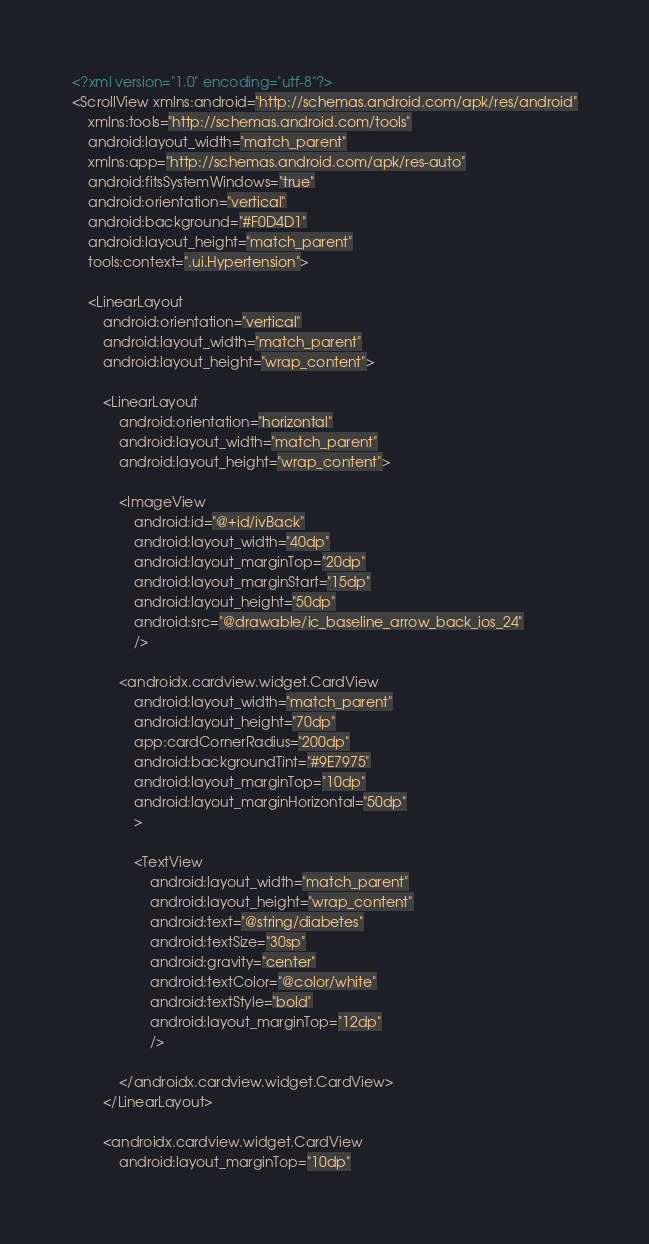<code> <loc_0><loc_0><loc_500><loc_500><_XML_><?xml version="1.0" encoding="utf-8"?>
<ScrollView xmlns:android="http://schemas.android.com/apk/res/android"
    xmlns:tools="http://schemas.android.com/tools"
    android:layout_width="match_parent"
    xmlns:app="http://schemas.android.com/apk/res-auto"
    android:fitsSystemWindows="true"
    android:orientation="vertical"
    android:background="#F0D4D1"
    android:layout_height="match_parent"
    tools:context=".ui.Hypertension">

    <LinearLayout
        android:orientation="vertical"
        android:layout_width="match_parent"
        android:layout_height="wrap_content">

        <LinearLayout
            android:orientation="horizontal"
            android:layout_width="match_parent"
            android:layout_height="wrap_content">

            <ImageView
                android:id="@+id/ivBack"
                android:layout_width="40dp"
                android:layout_marginTop="20dp"
                android:layout_marginStart="15dp"
                android:layout_height="50dp"
                android:src="@drawable/ic_baseline_arrow_back_ios_24"
                />

            <androidx.cardview.widget.CardView
                android:layout_width="match_parent"
                android:layout_height="70dp"
                app:cardCornerRadius="200dp"
                android:backgroundTint="#9E7975"
                android:layout_marginTop="10dp"
                android:layout_marginHorizontal="50dp"
                >

                <TextView
                    android:layout_width="match_parent"
                    android:layout_height="wrap_content"
                    android:text="@string/diabetes"
                    android:textSize="30sp"
                    android:gravity="center"
                    android:textColor="@color/white"
                    android:textStyle="bold"
                    android:layout_marginTop="12dp"
                    />

            </androidx.cardview.widget.CardView>
        </LinearLayout>

        <androidx.cardview.widget.CardView
            android:layout_marginTop="10dp"</code> 